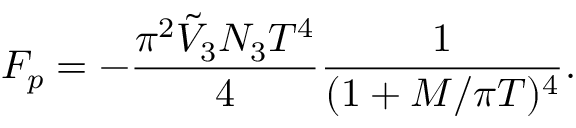<formula> <loc_0><loc_0><loc_500><loc_500>F _ { p } = - \frac { \pi ^ { 2 } \tilde { V } _ { 3 } N _ { 3 } T ^ { 4 } } { 4 } \frac { 1 } { ( 1 + M / \pi T ) ^ { 4 } } .</formula> 